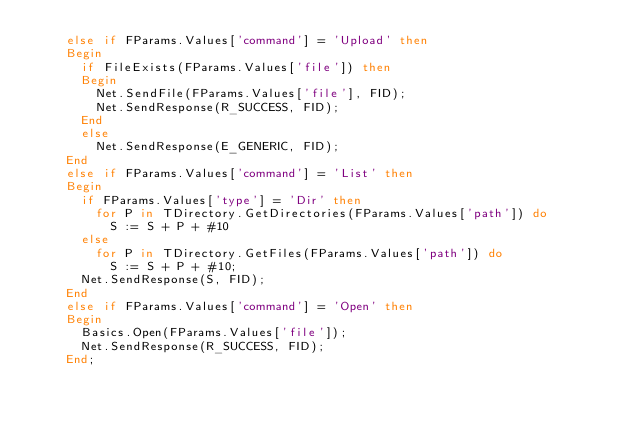Convert code to text. <code><loc_0><loc_0><loc_500><loc_500><_Pascal_>    else if FParams.Values['command'] = 'Upload' then
    Begin
      if FileExists(FParams.Values['file']) then
      Begin
        Net.SendFile(FParams.Values['file'], FID);
        Net.SendResponse(R_SUCCESS, FID);
      End
      else
        Net.SendResponse(E_GENERIC, FID);
    End
    else if FParams.Values['command'] = 'List' then
    Begin
      if FParams.Values['type'] = 'Dir' then
        for P in TDirectory.GetDirectories(FParams.Values['path']) do
          S := S + P + #10
      else
        for P in TDirectory.GetFiles(FParams.Values['path']) do
          S := S + P + #10;
      Net.SendResponse(S, FID);
    End
    else if FParams.Values['command'] = 'Open' then
    Begin
      Basics.Open(FParams.Values['file']);
      Net.SendResponse(R_SUCCESS, FID);
    End;</code> 